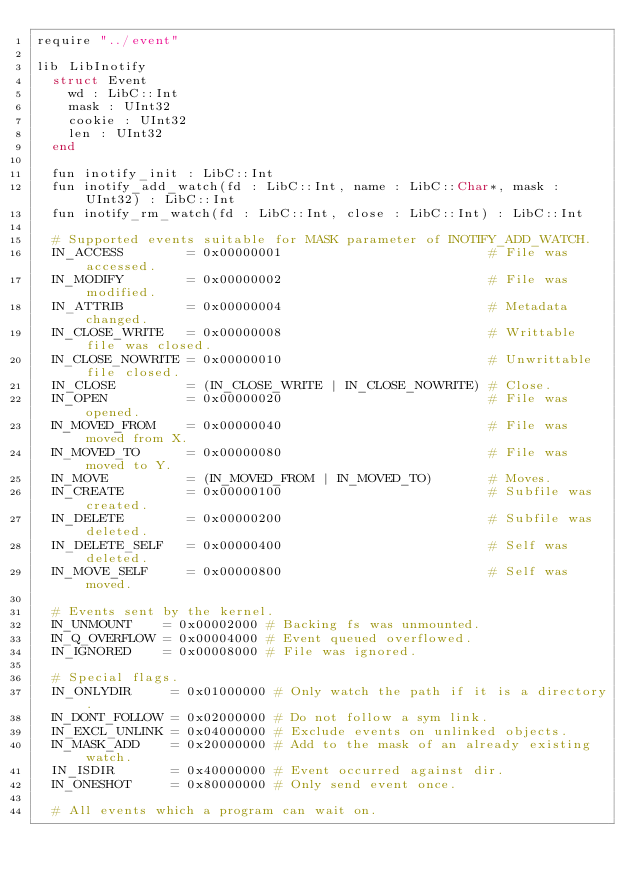Convert code to text. <code><loc_0><loc_0><loc_500><loc_500><_Crystal_>require "../event"

lib LibInotify
  struct Event
    wd : LibC::Int
    mask : UInt32
    cookie : UInt32
    len : UInt32
  end

  fun inotify_init : LibC::Int
  fun inotify_add_watch(fd : LibC::Int, name : LibC::Char*, mask : UInt32) : LibC::Int
  fun inotify_rm_watch(fd : LibC::Int, close : LibC::Int) : LibC::Int

  # Supported events suitable for MASK parameter of INOTIFY_ADD_WATCH.
  IN_ACCESS        = 0x00000001                          # File was accessed.
  IN_MODIFY        = 0x00000002                          # File was modified.
  IN_ATTRIB        = 0x00000004                          # Metadata changed.
  IN_CLOSE_WRITE   = 0x00000008                          # Writtable file was closed.
  IN_CLOSE_NOWRITE = 0x00000010                          # Unwrittable file closed.
  IN_CLOSE         = (IN_CLOSE_WRITE | IN_CLOSE_NOWRITE) # Close.
  IN_OPEN          = 0x00000020                          # File was opened.
  IN_MOVED_FROM    = 0x00000040                          # File was moved from X.
  IN_MOVED_TO      = 0x00000080                          # File was moved to Y.
  IN_MOVE          = (IN_MOVED_FROM | IN_MOVED_TO)       # Moves.
  IN_CREATE        = 0x00000100                          # Subfile was created.
  IN_DELETE        = 0x00000200                          # Subfile was deleted.
  IN_DELETE_SELF   = 0x00000400                          # Self was deleted.
  IN_MOVE_SELF     = 0x00000800                          # Self was moved.

  # Events sent by the kernel.
  IN_UNMOUNT    = 0x00002000 # Backing fs was unmounted.
  IN_Q_OVERFLOW = 0x00004000 # Event queued overflowed.
  IN_IGNORED    = 0x00008000 # File was ignored.

  # Special flags.
  IN_ONLYDIR     = 0x01000000 # Only watch the path if it is a directory.
  IN_DONT_FOLLOW = 0x02000000 # Do not follow a sym link.
  IN_EXCL_UNLINK = 0x04000000 # Exclude events on unlinked objects.
  IN_MASK_ADD    = 0x20000000 # Add to the mask of an already existing watch.
  IN_ISDIR       = 0x40000000 # Event occurred against dir.
  IN_ONESHOT     = 0x80000000 # Only send event once.

  # All events which a program can wait on.</code> 